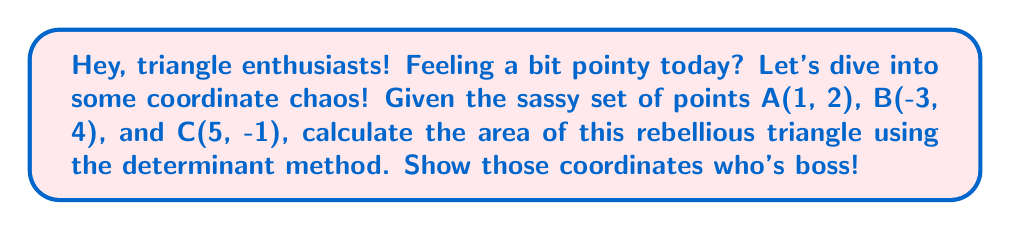Provide a solution to this math problem. Alright, let's tackle this with some mathematical sass:

1) First, we'll use the determinant formula for the area of a triangle:

   $$\text{Area} = \frac{1}{2}\left|\det\begin{pmatrix}
   x_1 & y_1 & 1 \\
   x_2 & y_2 & 1 \\
   x_3 & y_3 & 1
   \end{pmatrix}\right|$$

2) Plug in our coordinates like we're solving a puzzle:

   $$\text{Area} = \frac{1}{2}\left|\det\begin{pmatrix}
   1 & 2 & 1 \\
   -3 & 4 & 1 \\
   5 & -1 & 1
   \end{pmatrix}\right|$$

3) Time to expand this bad boy using the first row:

   $$\text{Area} = \frac{1}{2}\left|1\cdot\begin{vmatrix}4 & 1\\-1 & 1\end{vmatrix} - 2\cdot\begin{vmatrix}-3 & 1\\5 & 1\end{vmatrix} + 1\cdot\begin{vmatrix}-3 & 4\\5 & -1\end{vmatrix}\right|$$

4) Solve each 2x2 determinant like it owes you money:

   $$\text{Area} = \frac{1}{2}|1(4-(-1)) - 2((-3)-5) + 1((-3)(-1)-(4)(5))|$$

5) Simplify, because who doesn't love a good simplification?:

   $$\text{Area} = \frac{1}{2}|1(5) - 2(-8) + 1(-3+20)|$$
   $$\text{Area} = \frac{1}{2}|5 + 16 + 17|$$

6) And for the grand finale:

   $$\text{Area} = \frac{1}{2}|38| = 19$$

Voila! We've tamed this triangle with the power of determinants!
Answer: 19 square units 